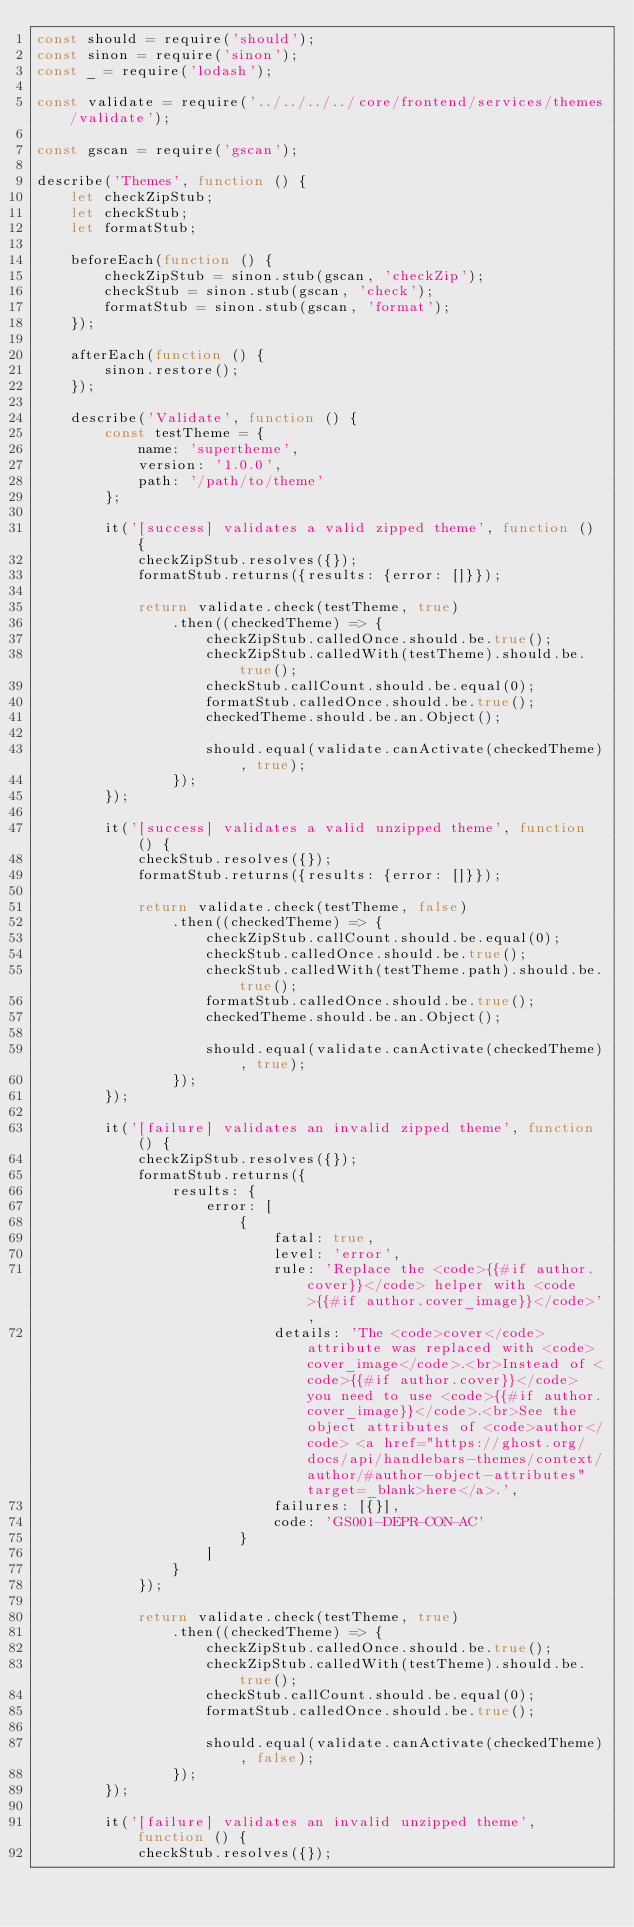<code> <loc_0><loc_0><loc_500><loc_500><_JavaScript_>const should = require('should');
const sinon = require('sinon');
const _ = require('lodash');

const validate = require('../../../../core/frontend/services/themes/validate');

const gscan = require('gscan');

describe('Themes', function () {
    let checkZipStub;
    let checkStub;
    let formatStub;

    beforeEach(function () {
        checkZipStub = sinon.stub(gscan, 'checkZip');
        checkStub = sinon.stub(gscan, 'check');
        formatStub = sinon.stub(gscan, 'format');
    });

    afterEach(function () {
        sinon.restore();
    });

    describe('Validate', function () {
        const testTheme = {
            name: 'supertheme',
            version: '1.0.0',
            path: '/path/to/theme'
        };

        it('[success] validates a valid zipped theme', function () {
            checkZipStub.resolves({});
            formatStub.returns({results: {error: []}});

            return validate.check(testTheme, true)
                .then((checkedTheme) => {
                    checkZipStub.calledOnce.should.be.true();
                    checkZipStub.calledWith(testTheme).should.be.true();
                    checkStub.callCount.should.be.equal(0);
                    formatStub.calledOnce.should.be.true();
                    checkedTheme.should.be.an.Object();

                    should.equal(validate.canActivate(checkedTheme), true);
                });
        });

        it('[success] validates a valid unzipped theme', function () {
            checkStub.resolves({});
            formatStub.returns({results: {error: []}});

            return validate.check(testTheme, false)
                .then((checkedTheme) => {
                    checkZipStub.callCount.should.be.equal(0);
                    checkStub.calledOnce.should.be.true();
                    checkStub.calledWith(testTheme.path).should.be.true();
                    formatStub.calledOnce.should.be.true();
                    checkedTheme.should.be.an.Object();

                    should.equal(validate.canActivate(checkedTheme), true);
                });
        });

        it('[failure] validates an invalid zipped theme', function () {
            checkZipStub.resolves({});
            formatStub.returns({
                results: {
                    error: [
                        {
                            fatal: true,
                            level: 'error',
                            rule: 'Replace the <code>{{#if author.cover}}</code> helper with <code>{{#if author.cover_image}}</code>',
                            details: 'The <code>cover</code> attribute was replaced with <code>cover_image</code>.<br>Instead of <code>{{#if author.cover}}</code> you need to use <code>{{#if author.cover_image}}</code>.<br>See the object attributes of <code>author</code> <a href="https://ghost.org/docs/api/handlebars-themes/context/author/#author-object-attributes" target=_blank>here</a>.',
                            failures: [{}],
                            code: 'GS001-DEPR-CON-AC'
                        }
                    ]
                }
            });

            return validate.check(testTheme, true)
                .then((checkedTheme) => {
                    checkZipStub.calledOnce.should.be.true();
                    checkZipStub.calledWith(testTheme).should.be.true();
                    checkStub.callCount.should.be.equal(0);
                    formatStub.calledOnce.should.be.true();

                    should.equal(validate.canActivate(checkedTheme), false);
                });
        });

        it('[failure] validates an invalid unzipped theme', function () {
            checkStub.resolves({});</code> 